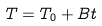<formula> <loc_0><loc_0><loc_500><loc_500>T = T _ { 0 } + B t</formula> 